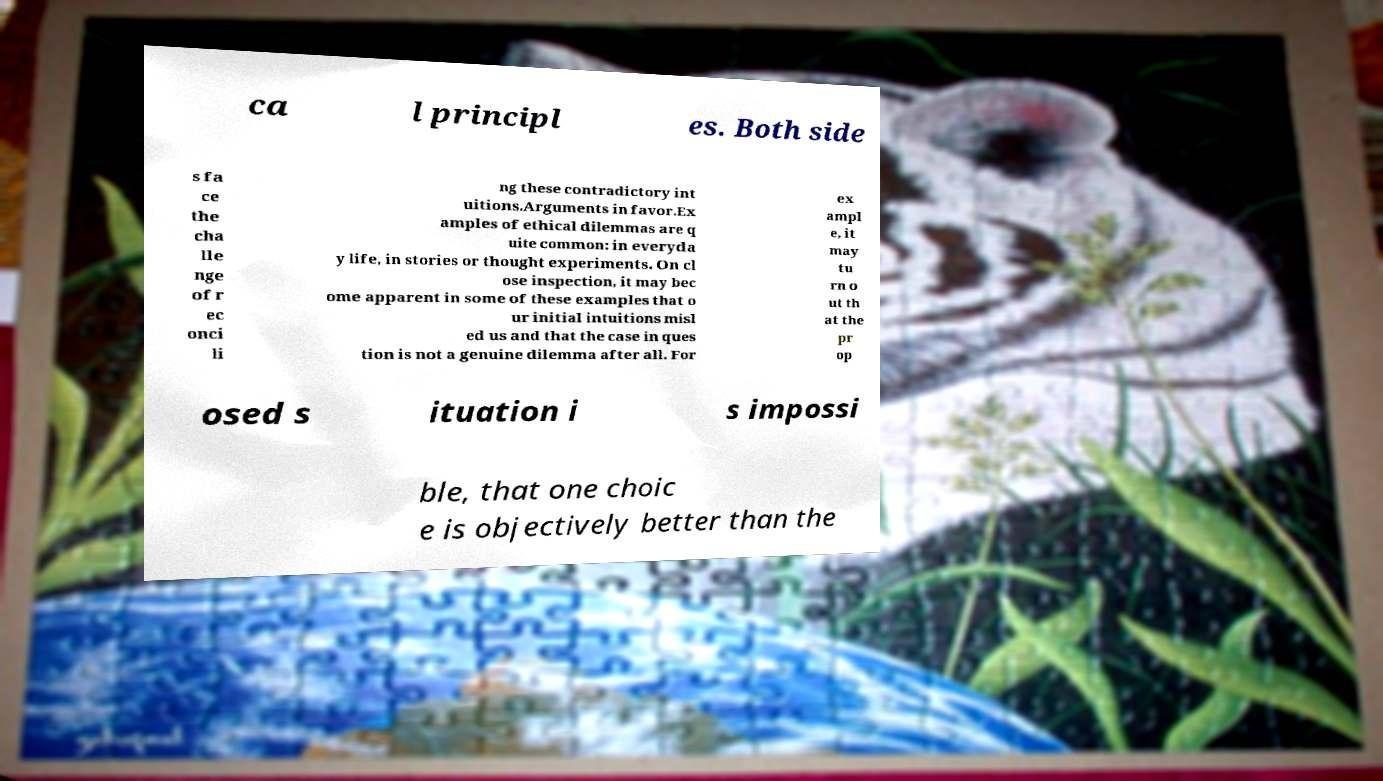Please read and relay the text visible in this image. What does it say? ca l principl es. Both side s fa ce the cha lle nge of r ec onci li ng these contradictory int uitions.Arguments in favor.Ex amples of ethical dilemmas are q uite common: in everyda y life, in stories or thought experiments. On cl ose inspection, it may bec ome apparent in some of these examples that o ur initial intuitions misl ed us and that the case in ques tion is not a genuine dilemma after all. For ex ampl e, it may tu rn o ut th at the pr op osed s ituation i s impossi ble, that one choic e is objectively better than the 